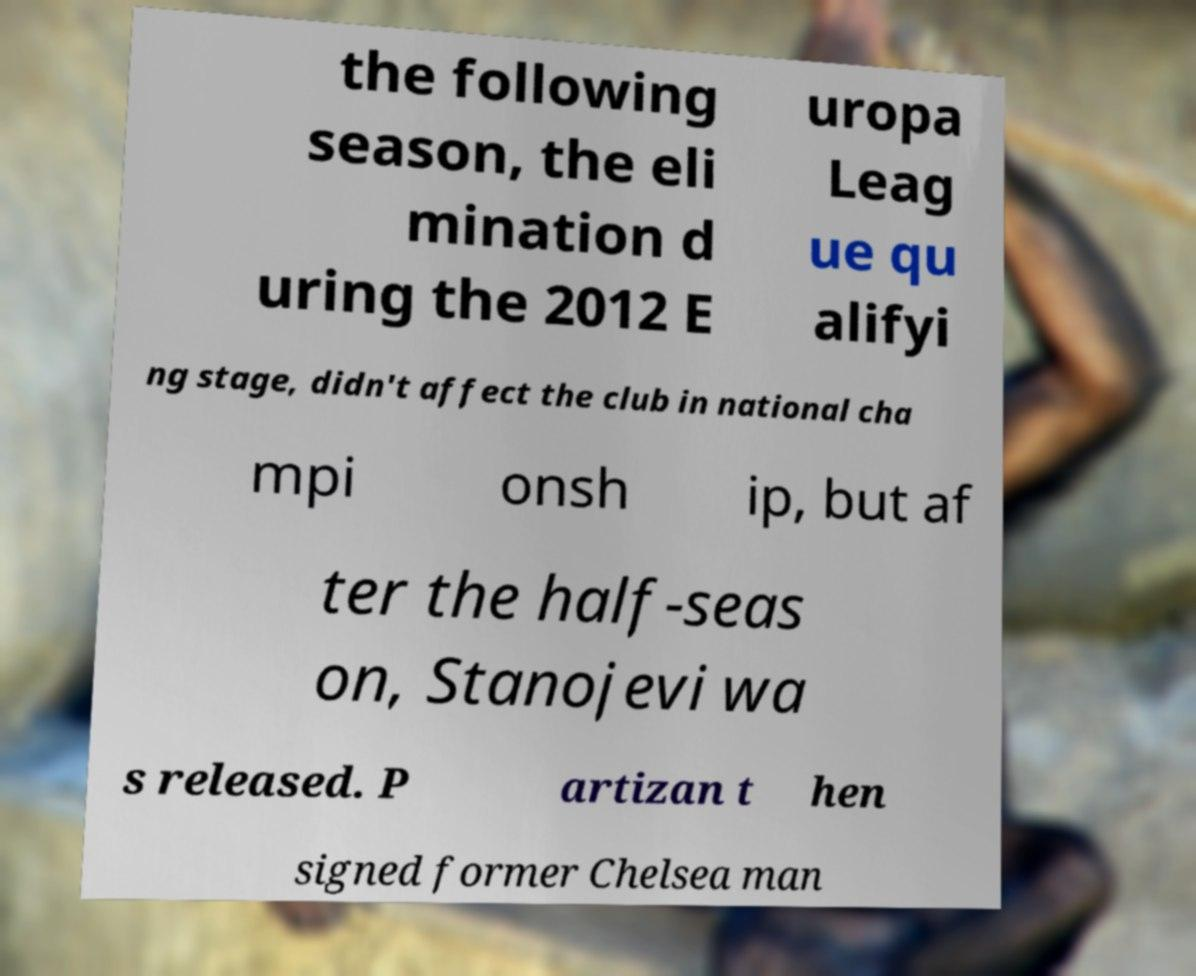I need the written content from this picture converted into text. Can you do that? the following season, the eli mination d uring the 2012 E uropa Leag ue qu alifyi ng stage, didn't affect the club in national cha mpi onsh ip, but af ter the half-seas on, Stanojevi wa s released. P artizan t hen signed former Chelsea man 